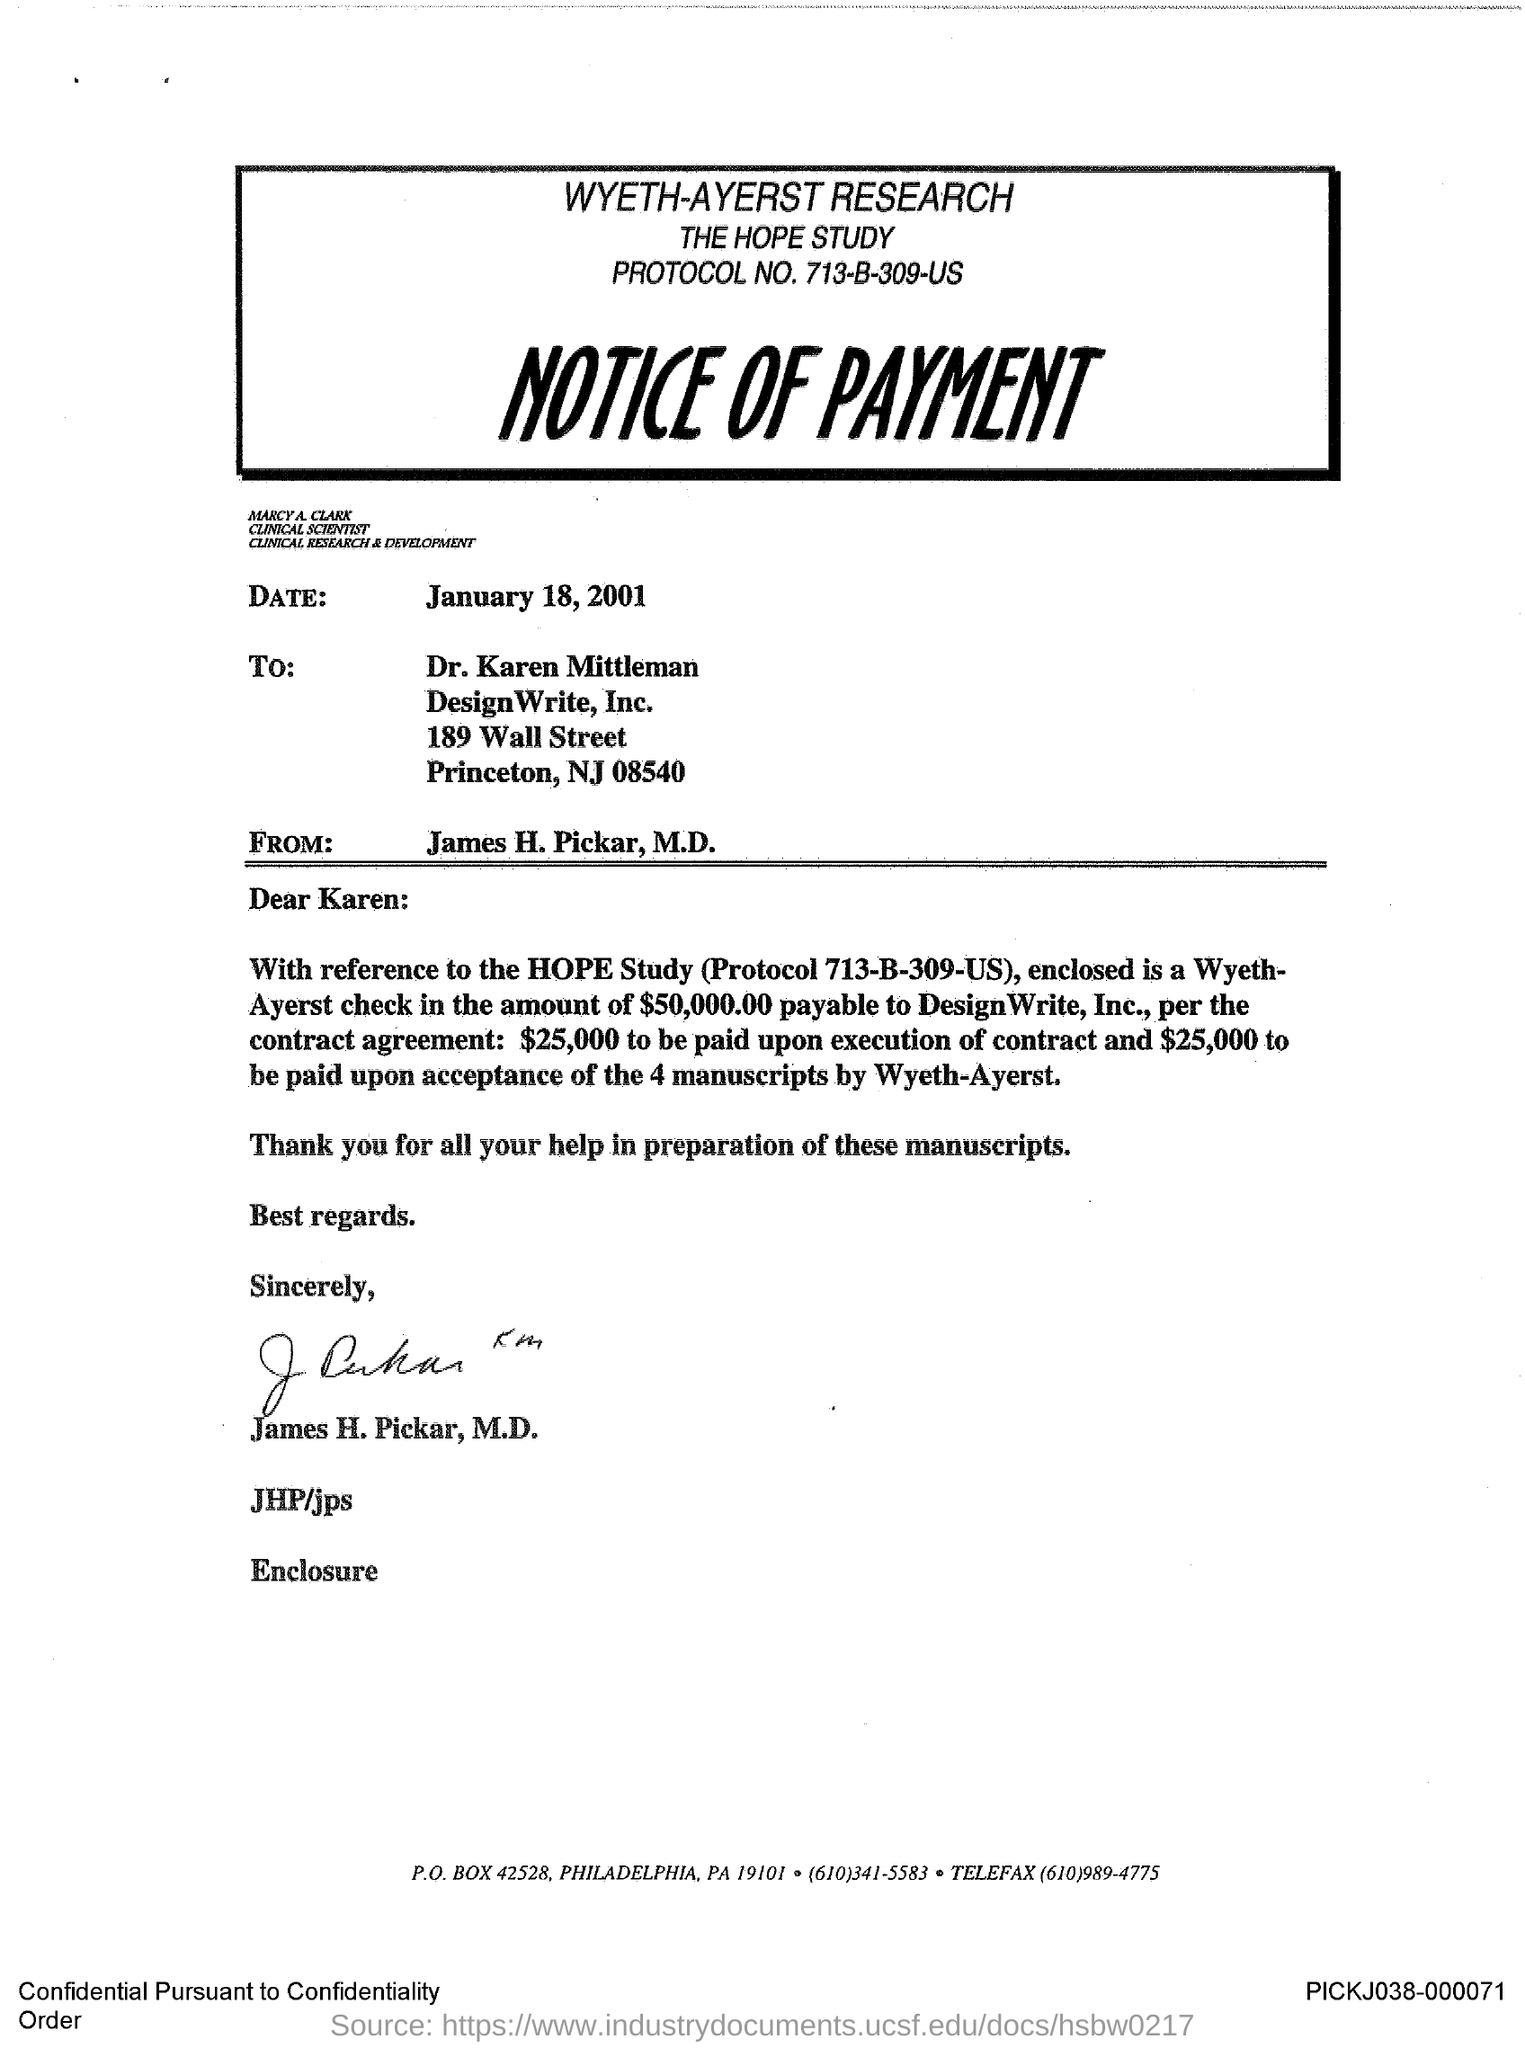Point out several critical features in this image. The document mentions that the date is January 18, 2001. James H. Pickar has signed the document. The document provided is a Notice of Payment. The document is addressed to Dr. Karen Mittleman. 